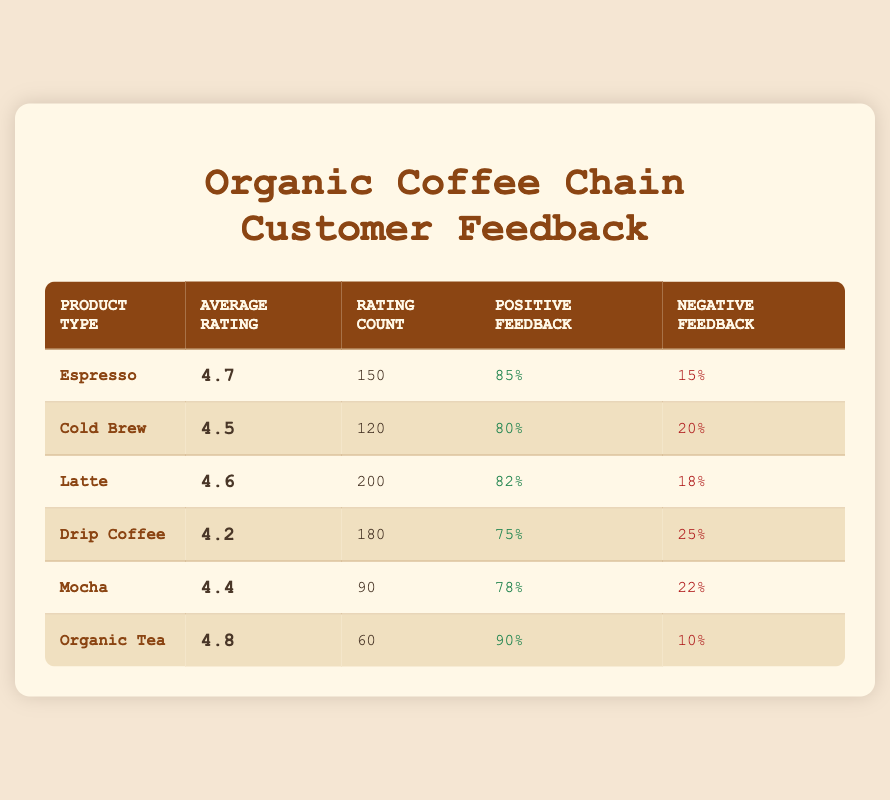What is the average rating of the Organic Tea product type? The average rating for Organic Tea is directly listed in the table under the Average Rating column, which is 4.8.
Answer: 4.8 Which product type received the highest percentage of positive feedback? Looking at the Positive Feedback column, Organic Tea holds the highest percentage at 90%.
Answer: Organic Tea How many total ratings were provided for all products combined? To find the total ratings, I add up the Rating Count column for all product types: 150 + 120 + 200 + 180 + 90 + 60 = 900.
Answer: 900 Is the average rating for the Drip Coffee greater than the average rating for the Mocha? The average rating for Drip Coffee is 4.2 and for Mocha is 4.4. Since 4.2 is less than 4.4, the statement is false.
Answer: No What is the difference in positive feedback percentage between the Latte and Cold Brew? The positive feedback for Latte is 82% and for Cold Brew is 80%. The difference is: 82% - 80% = 2%.
Answer: 2% Which product type has a rating count below 100? By inspecting the Rating Count column, we see that Organic Tea has a rating count of 60, which is the only value below 100.
Answer: Organic Tea What is the average rating across all product types? To find the average rating, I sum all average ratings: (4.7 + 4.5 + 4.6 + 4.2 + 4.4 + 4.8) = 27.2, then divide by the number of products, which is 6. Thus, the average is 27.2 / 6 = 4.53.
Answer: 4.53 What percentage of feedback for the Espresso was negative? The Negative Feedback column states that the percentage of negative feedback for Espresso is 15%. This is directly taken from the table.
Answer: 15% Which product has the highest rating count? The Rating Count for Latte is 200, which is the highest compared to all the other products in the table.
Answer: Latte 